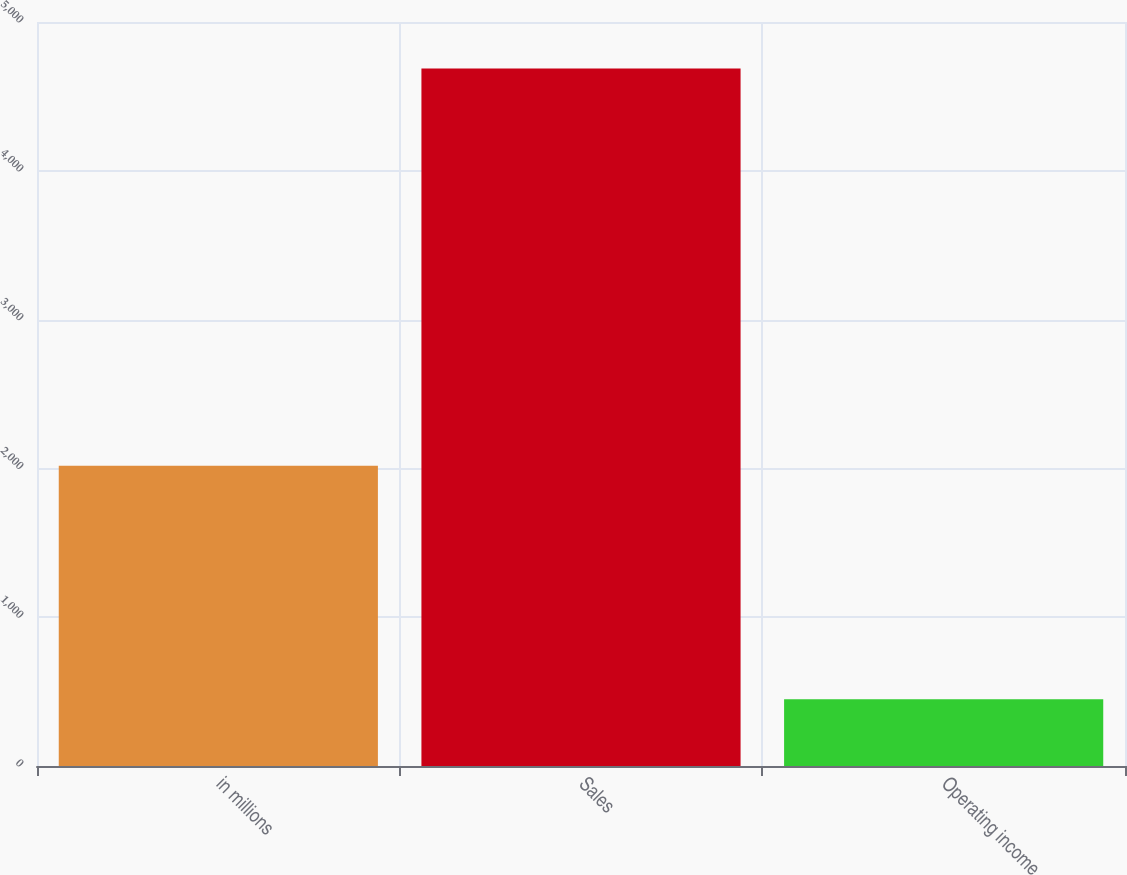Convert chart. <chart><loc_0><loc_0><loc_500><loc_500><bar_chart><fcel>in millions<fcel>Sales<fcel>Operating income<nl><fcel>2017<fcel>4687<fcel>449<nl></chart> 